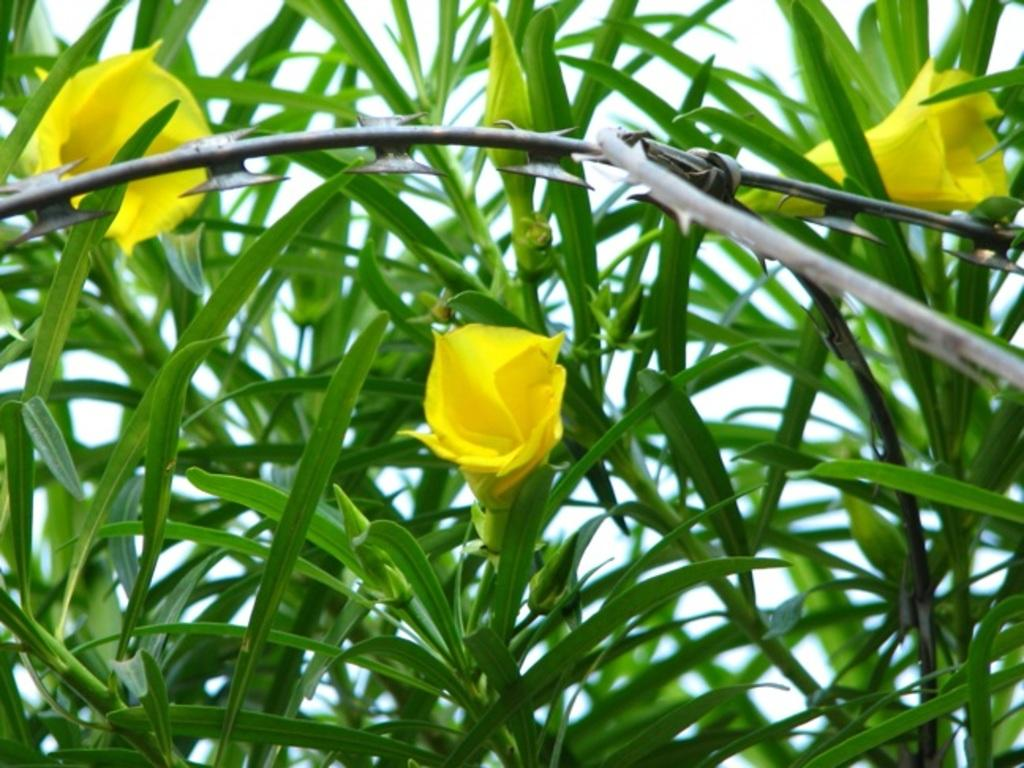Where was the image taken? The image was taken outdoors. What can be seen in the image besides the outdoor setting? There is a plant in the image. What are the characteristics of the plant? The plant has green leaves and yellow flowers. How many mice are hiding among the plant's leaves in the image? There are no mice present in the image; it only features a plant with green leaves and yellow flowers. What type of jewel can be seen hanging from the plant's stem in the image? There is no jewel present in the image; it only features a plant with green leaves and yellow flowers. 